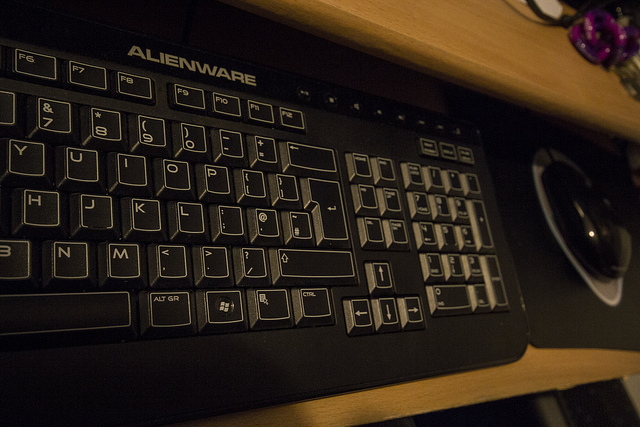Please extract the text content from this image. ALIENWARE F6 8 9 o ALT GR B H J k L M N Y U I O P 7 & 